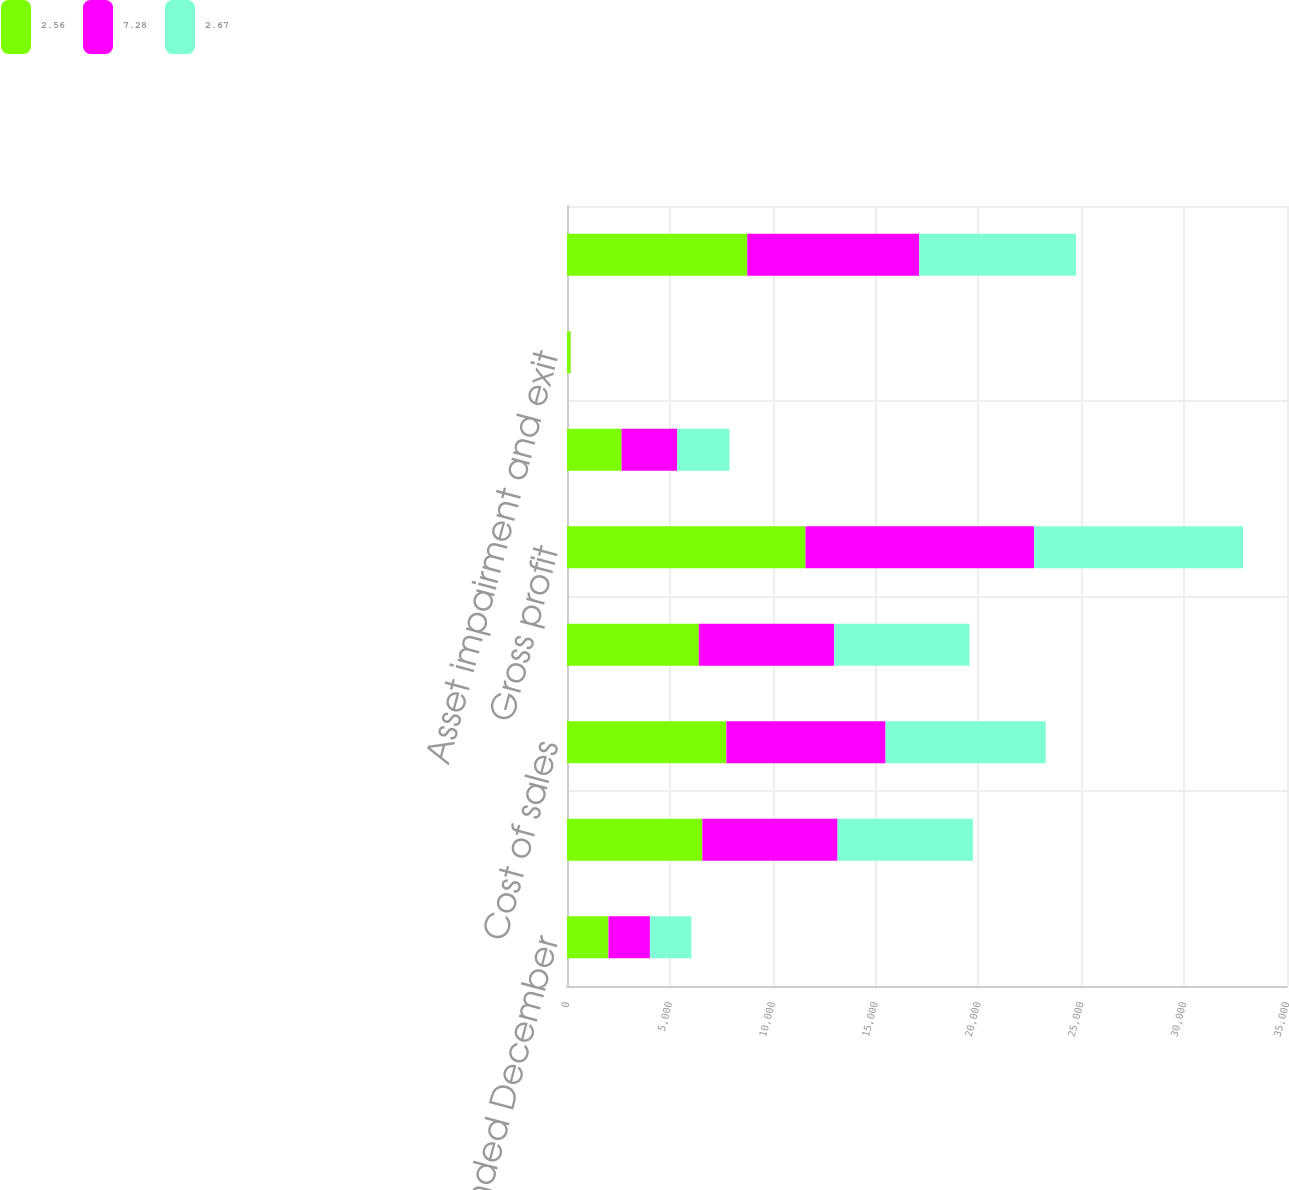<chart> <loc_0><loc_0><loc_500><loc_500><stacked_bar_chart><ecel><fcel>for the years ended December<fcel>Net revenues<fcel>Cost of sales<fcel>Excise taxes on products<fcel>Gross profit<fcel>Marketing administration and<fcel>Asset impairment and exit<fcel>Operating income<nl><fcel>2.56<fcel>2016<fcel>6577<fcel>7746<fcel>6407<fcel>11591<fcel>2650<fcel>179<fcel>8762<nl><fcel>7.28<fcel>2015<fcel>6577<fcel>7740<fcel>6580<fcel>11114<fcel>2708<fcel>4<fcel>8361<nl><fcel>2.67<fcel>2014<fcel>6577<fcel>7785<fcel>6577<fcel>10160<fcel>2539<fcel>1<fcel>7620<nl></chart> 